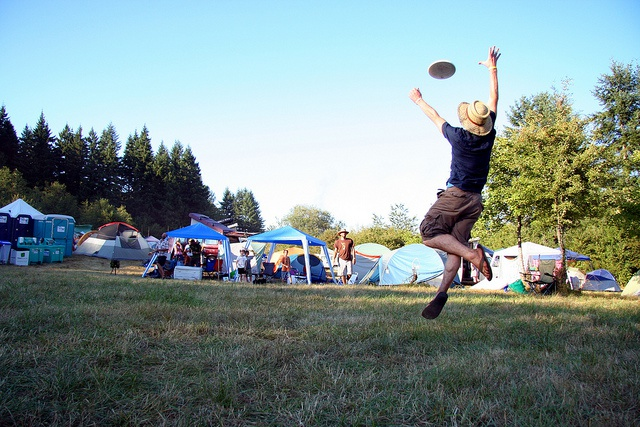Describe the objects in this image and their specific colors. I can see people in lightblue, black, ivory, and gray tones, people in lightblue, white, salmon, brown, and black tones, umbrella in lightblue and white tones, umbrella in lightblue, blue, gray, and darkgray tones, and frisbee in lightblue, gray, violet, and lavender tones in this image. 